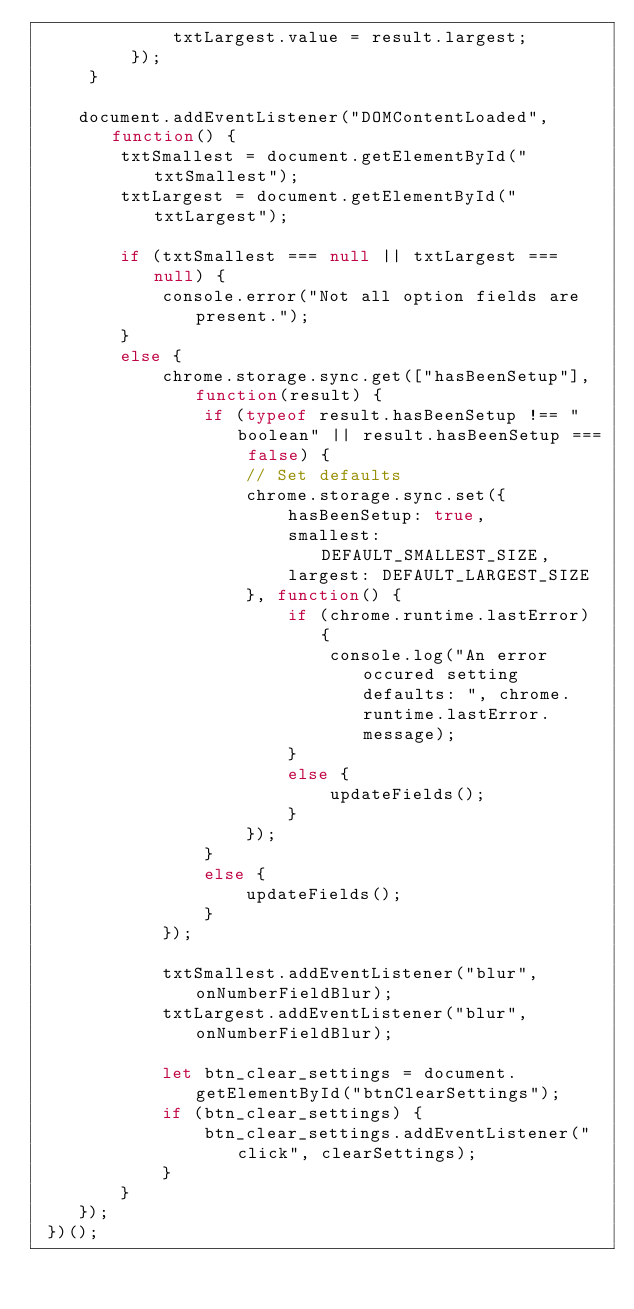Convert code to text. <code><loc_0><loc_0><loc_500><loc_500><_JavaScript_>             txtLargest.value = result.largest;
         });
     }

    document.addEventListener("DOMContentLoaded", function() {
        txtSmallest = document.getElementById("txtSmallest");
        txtLargest = document.getElementById("txtLargest");

        if (txtSmallest === null || txtLargest === null) {
            console.error("Not all option fields are present.");
        }
        else {
            chrome.storage.sync.get(["hasBeenSetup"], function(result) {
                if (typeof result.hasBeenSetup !== "boolean" || result.hasBeenSetup === false) {
                    // Set defaults
                    chrome.storage.sync.set({
                        hasBeenSetup: true,
                        smallest: DEFAULT_SMALLEST_SIZE,
                        largest: DEFAULT_LARGEST_SIZE
                    }, function() {
                        if (chrome.runtime.lastError) {
                            console.log("An error occured setting defaults: ", chrome.runtime.lastError.message);
                        }
                        else {
                            updateFields();
                        }
                    });
                }
                else {
                    updateFields();
                }
            });

            txtSmallest.addEventListener("blur", onNumberFieldBlur);
            txtLargest.addEventListener("blur", onNumberFieldBlur);

            let btn_clear_settings = document.getElementById("btnClearSettings");
            if (btn_clear_settings) {
                btn_clear_settings.addEventListener("click", clearSettings);
            }
        }
    });
 })();
</code> 